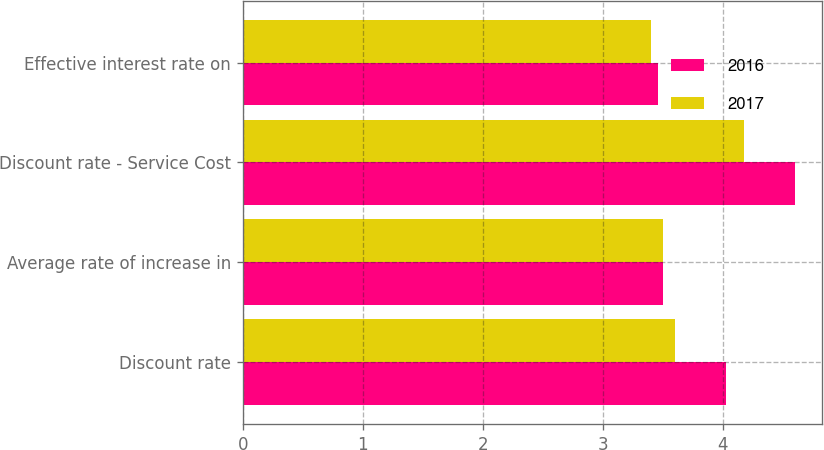Convert chart to OTSL. <chart><loc_0><loc_0><loc_500><loc_500><stacked_bar_chart><ecel><fcel>Discount rate<fcel>Average rate of increase in<fcel>Discount rate - Service Cost<fcel>Effective interest rate on<nl><fcel>2016<fcel>4.03<fcel>3.5<fcel>4.6<fcel>3.46<nl><fcel>2017<fcel>3.6<fcel>3.5<fcel>4.18<fcel>3.4<nl></chart> 